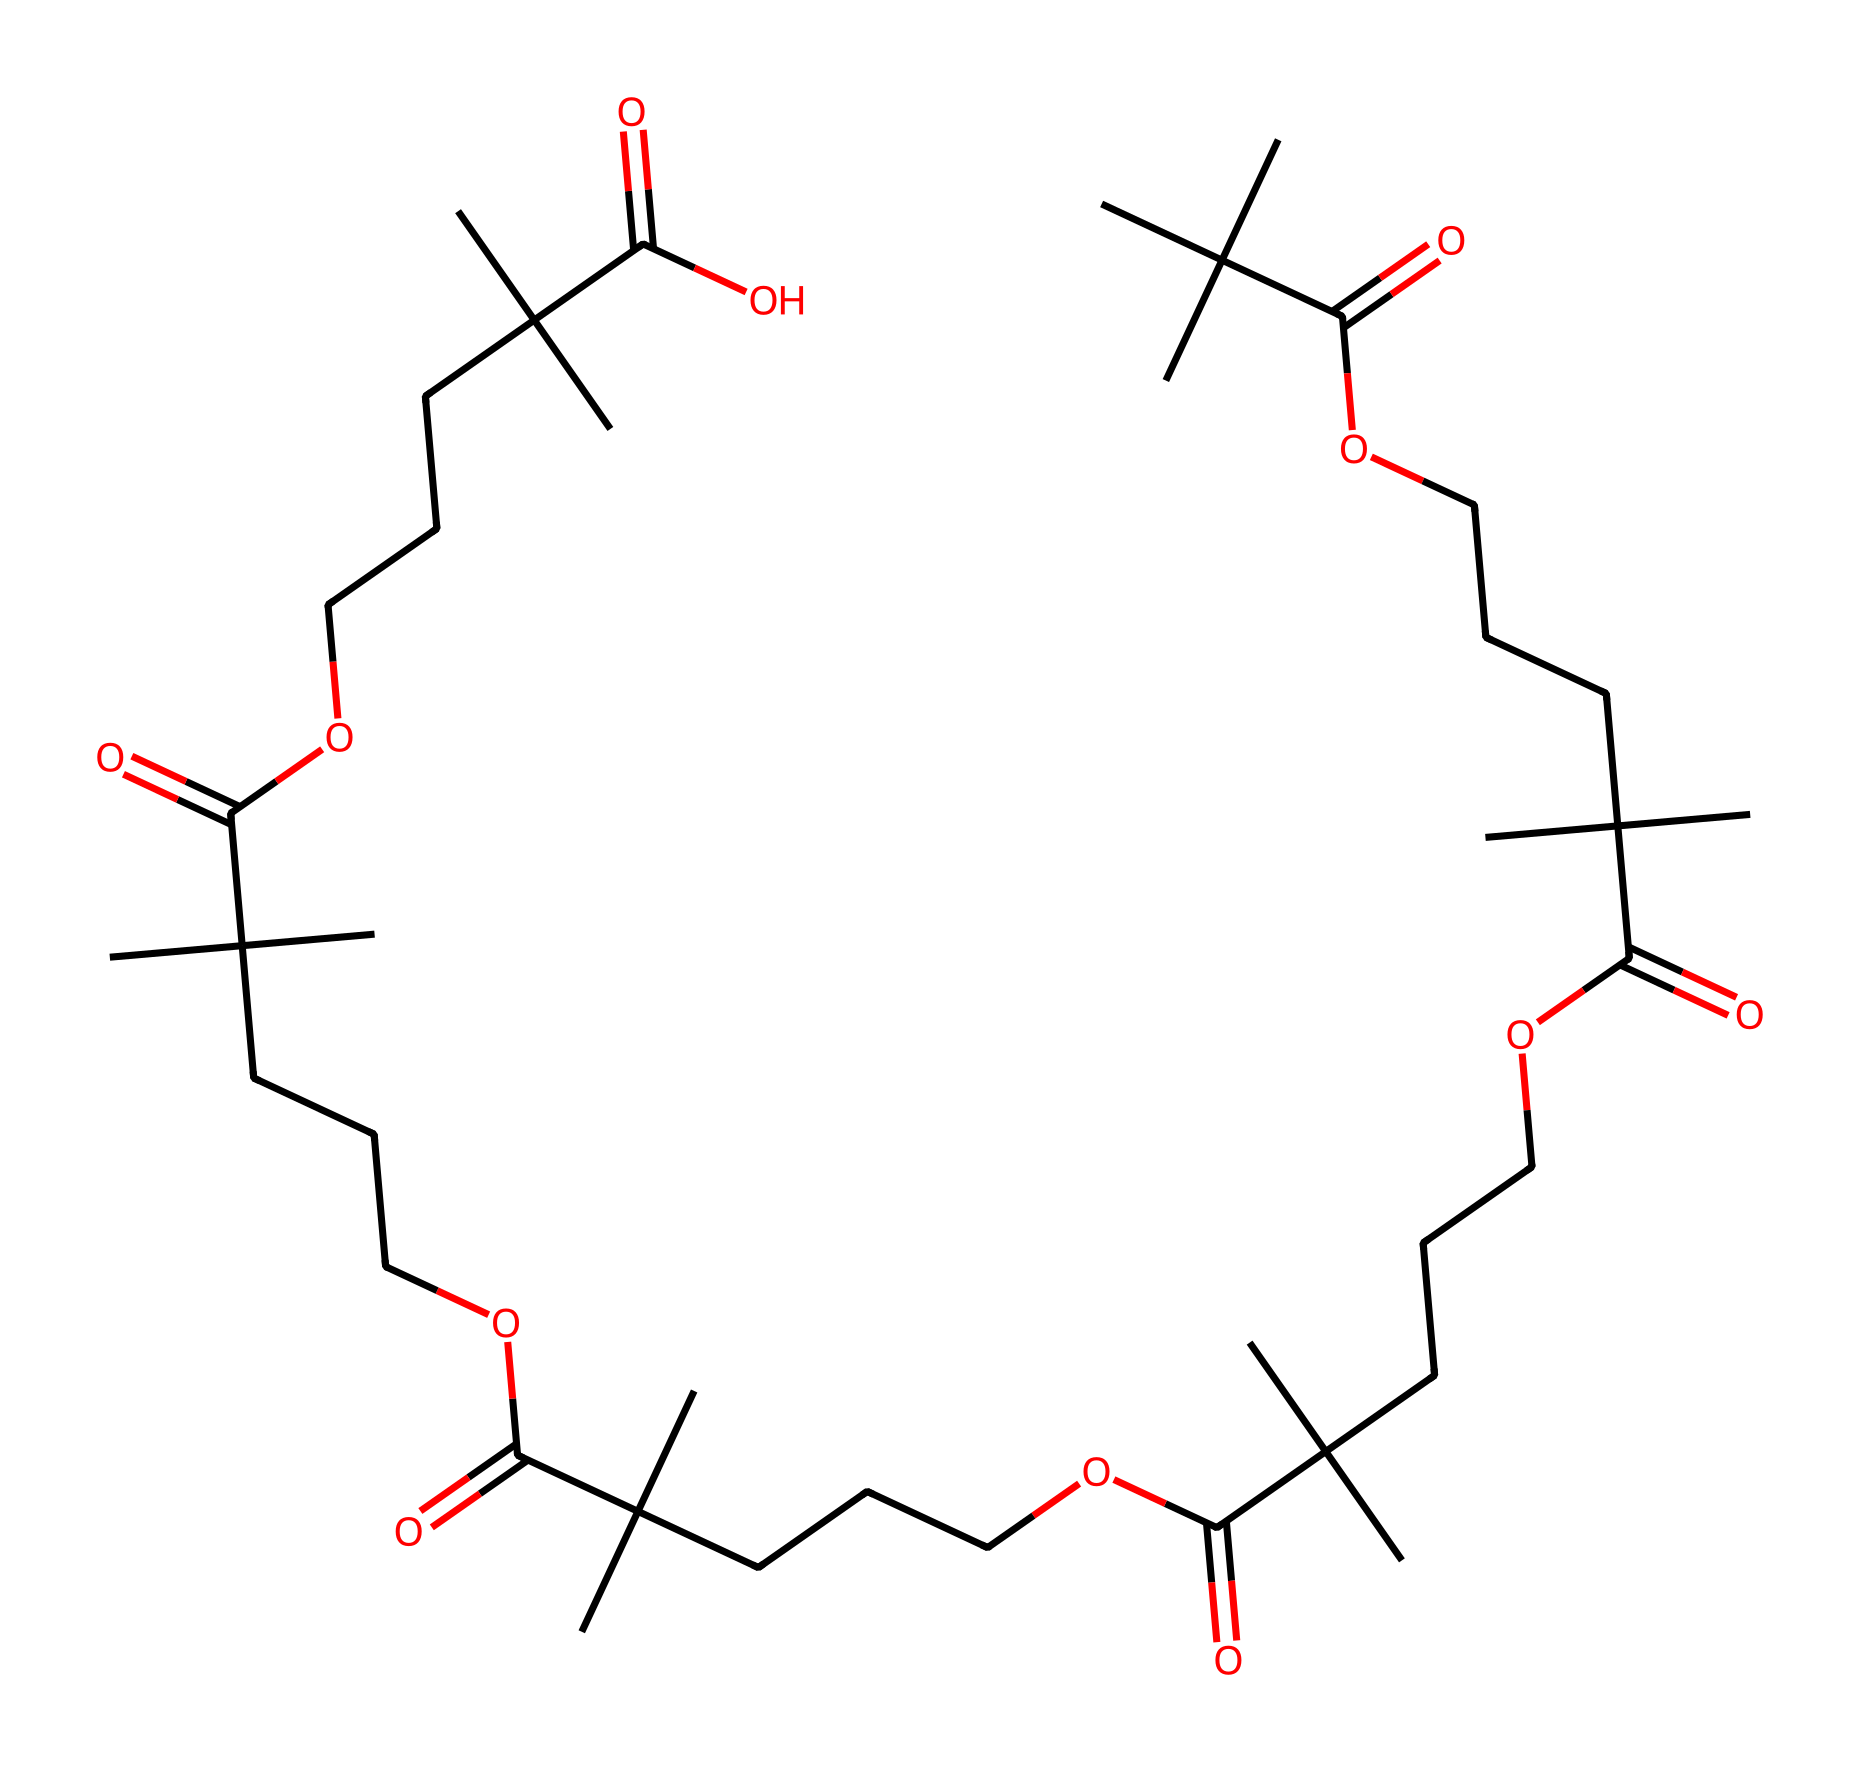How many carbon atoms are present in this polymer structure? Analyzing the SMILES representation, we count the "C" symbols. Each "C" represents a carbon atom. The structure shows many "C" atoms, with a total count yielding 30.
Answer: 30 What type of functional groups are present in this sunscreen polymer? Looking closely at the structure, the carboxylic acid groups, denoted by "C(=O)O," indicate the presence of carboxylic acids. These groups contribute to the polymer's solubility and film-forming properties.
Answer: carboxylic acids What determines the waterproof nature of this polymer? The repeated structure and the presence of hydrocarbon chains provide hydrophobic characteristics, which are crucial for achieving water resistance. Also, the combination of long carbon chains enhances the film-forming ability, helping maintain waterproof properties.
Answer: hydrophobic characteristics What is the repeating unit of this polymer structure? By examining the chemical’s structure, we can identify that the repeating unit consists of long carbon chains terminated by carboxylic acid groups. Evaluating the pattern helps in comprehending how these units link together sequentially, forming a polymer.
Answer: carbon chains with carboxylic acids How many total functional groups appear in this polymer? In the given structure, we see multiple instances of the carboxylic acid patterns. Counting the instances of "C(=O)O" reveals that there are 6 functional groups present, corresponding to the repeating units' endings.
Answer: 6 